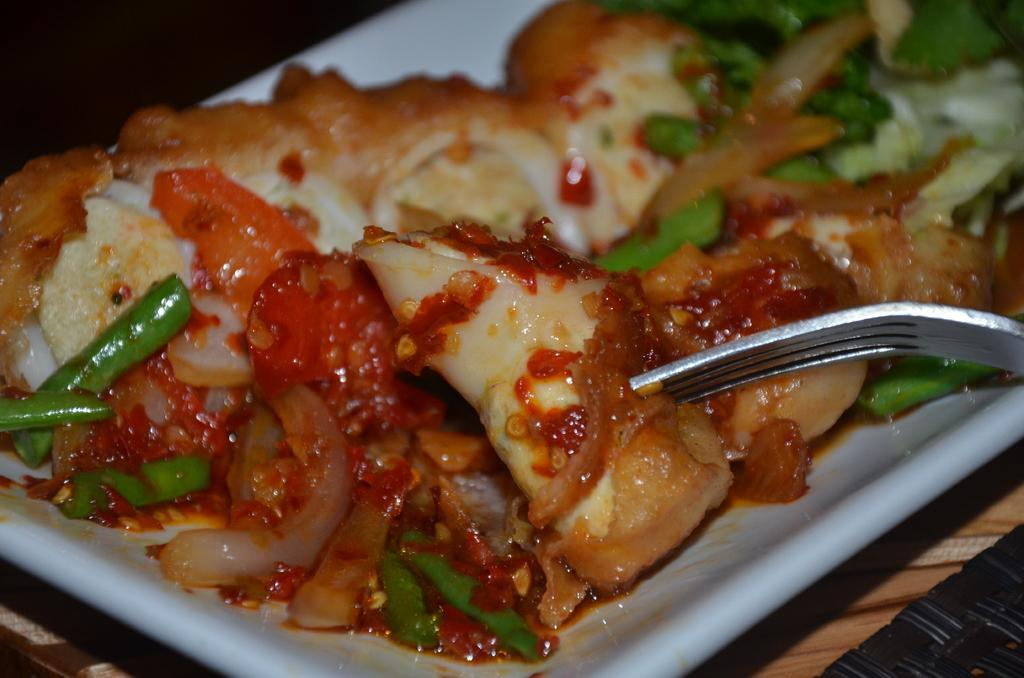What color is the plate in the image? The plate in the image is white. What is on the plate? There is food on the plate. What utensil is present on the plate? There is a fork kept in the plate. How many stars can be seen on the plate in the image? There are no stars present on the plate in the image. 